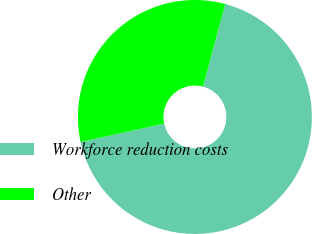<chart> <loc_0><loc_0><loc_500><loc_500><pie_chart><fcel>Workforce reduction costs<fcel>Other<nl><fcel>67.39%<fcel>32.61%<nl></chart> 